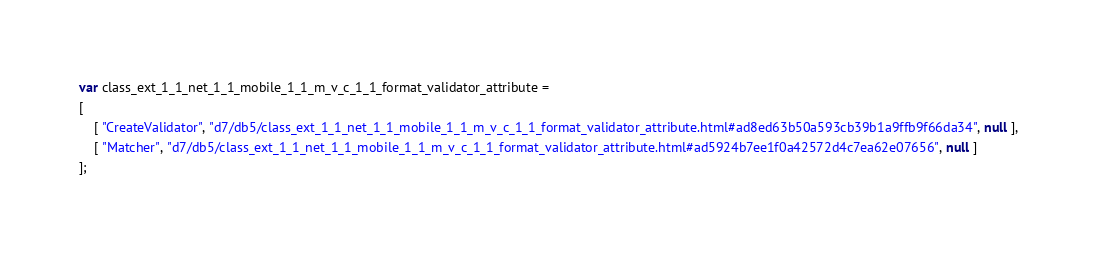<code> <loc_0><loc_0><loc_500><loc_500><_JavaScript_>var class_ext_1_1_net_1_1_mobile_1_1_m_v_c_1_1_format_validator_attribute =
[
    [ "CreateValidator", "d7/db5/class_ext_1_1_net_1_1_mobile_1_1_m_v_c_1_1_format_validator_attribute.html#ad8ed63b50a593cb39b1a9ffb9f66da34", null ],
    [ "Matcher", "d7/db5/class_ext_1_1_net_1_1_mobile_1_1_m_v_c_1_1_format_validator_attribute.html#ad5924b7ee1f0a42572d4c7ea62e07656", null ]
];</code> 